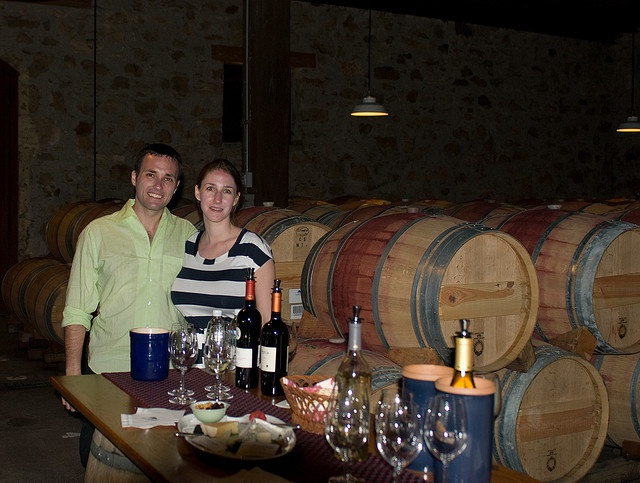Describe the objects in this image and their specific colors. I can see dining table in black, gray, and maroon tones, people in black, darkgray, tan, and gray tones, people in black, darkgray, gray, and tan tones, bowl in black, gray, and darkgray tones, and wine glass in black and gray tones in this image. 